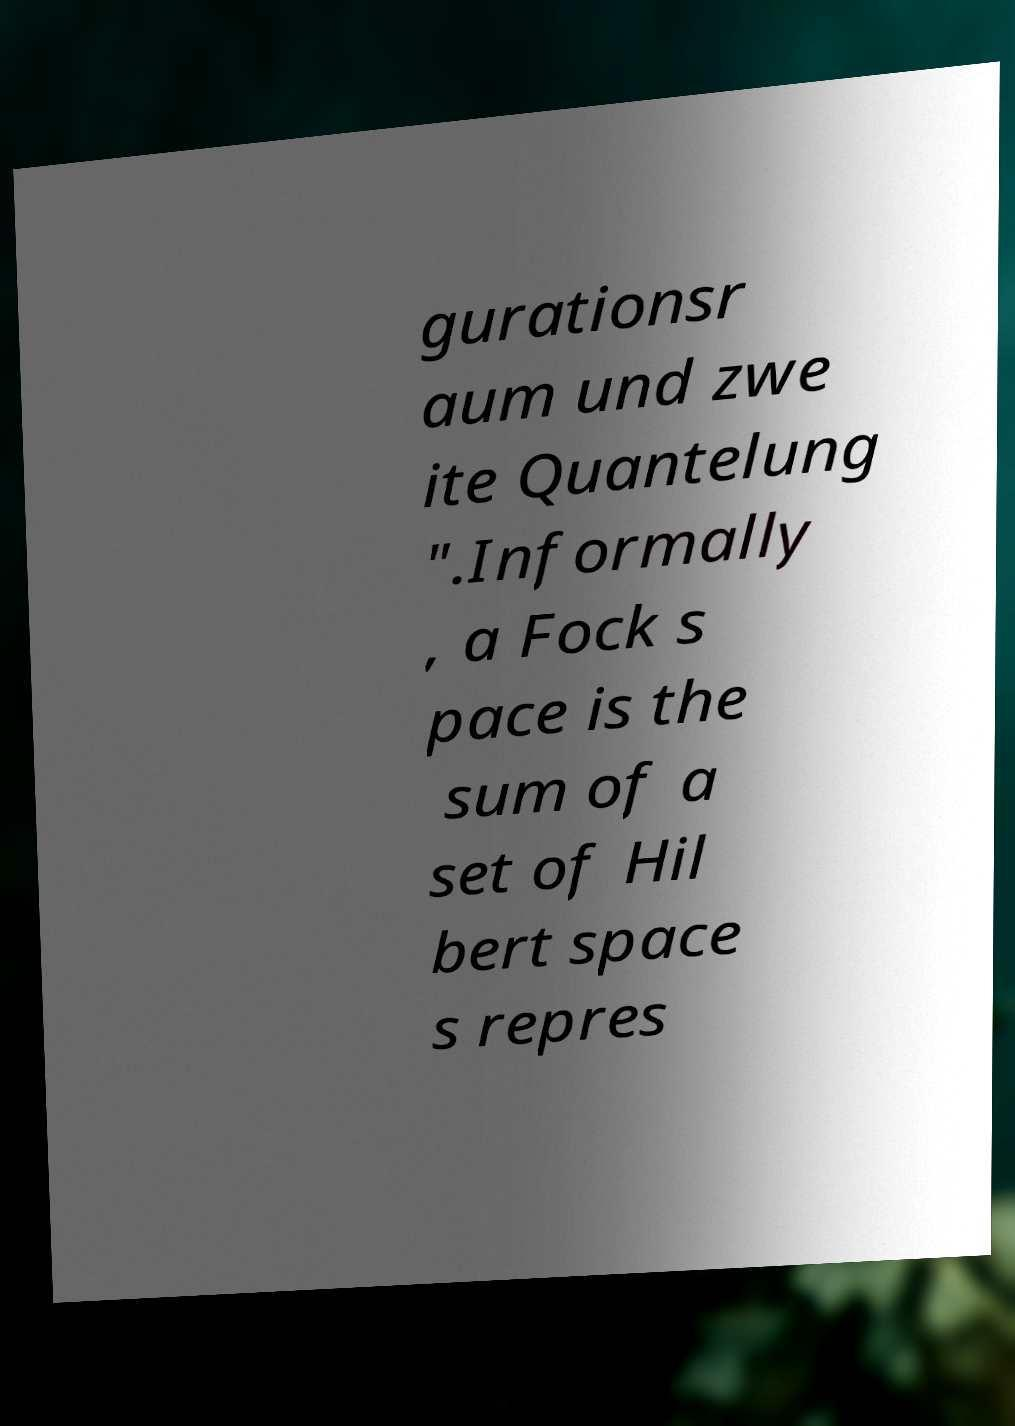Please identify and transcribe the text found in this image. gurationsr aum und zwe ite Quantelung ".Informally , a Fock s pace is the sum of a set of Hil bert space s repres 